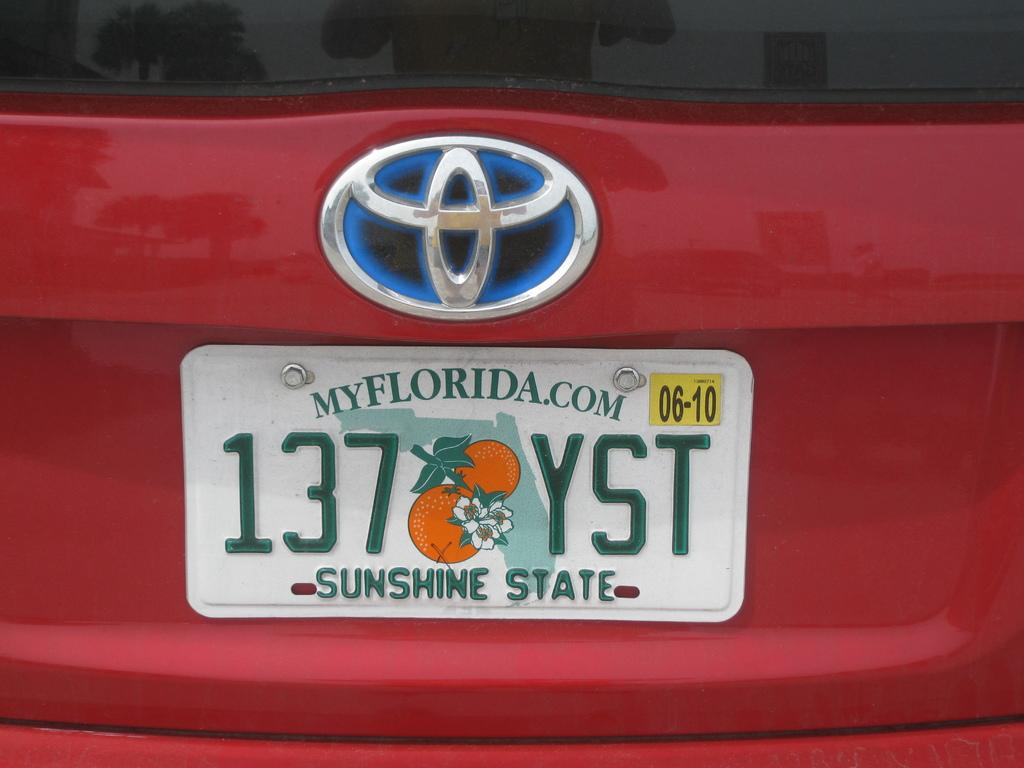<image>
Give a short and clear explanation of the subsequent image. A red Toyota has a license plate from the state of Florida. 